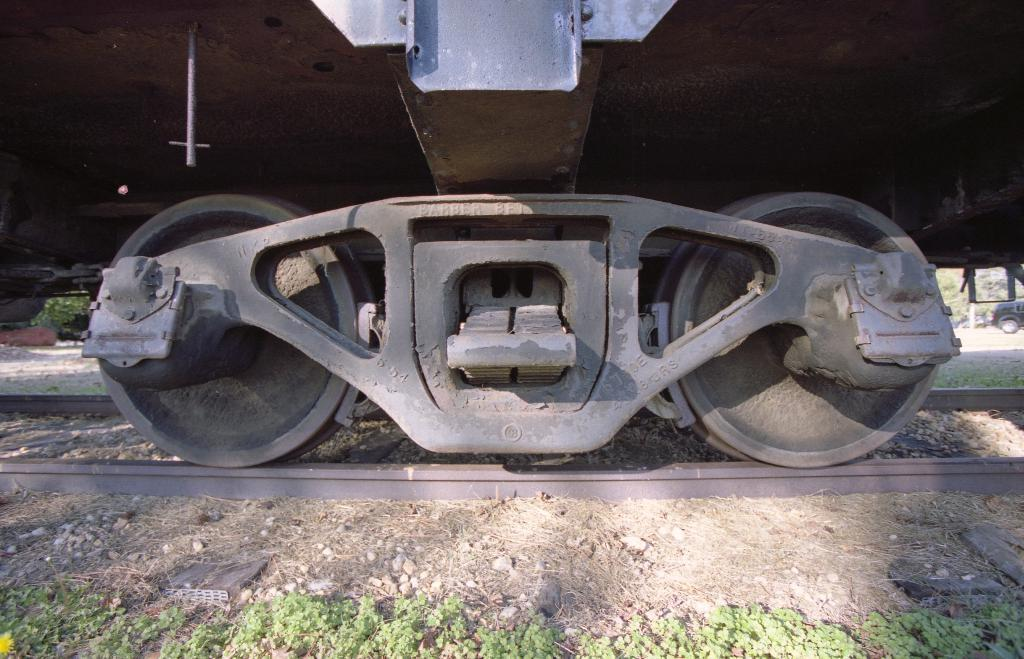What is the main subject of the image? The main subject of the image is a train wheel. Can you describe the setting of the train wheel? The train wheel is on a track. What color is the crayon used to draw the train wheel in the image? There is no crayon or drawing present in the image; it is a photograph of a real train wheel. What type of crack is visible on the train wheel in the image? There is no crack visible on the train wheel in the image. Is there a toothbrush used to clean the train wheel in the image? There is no toothbrush present in the image. 